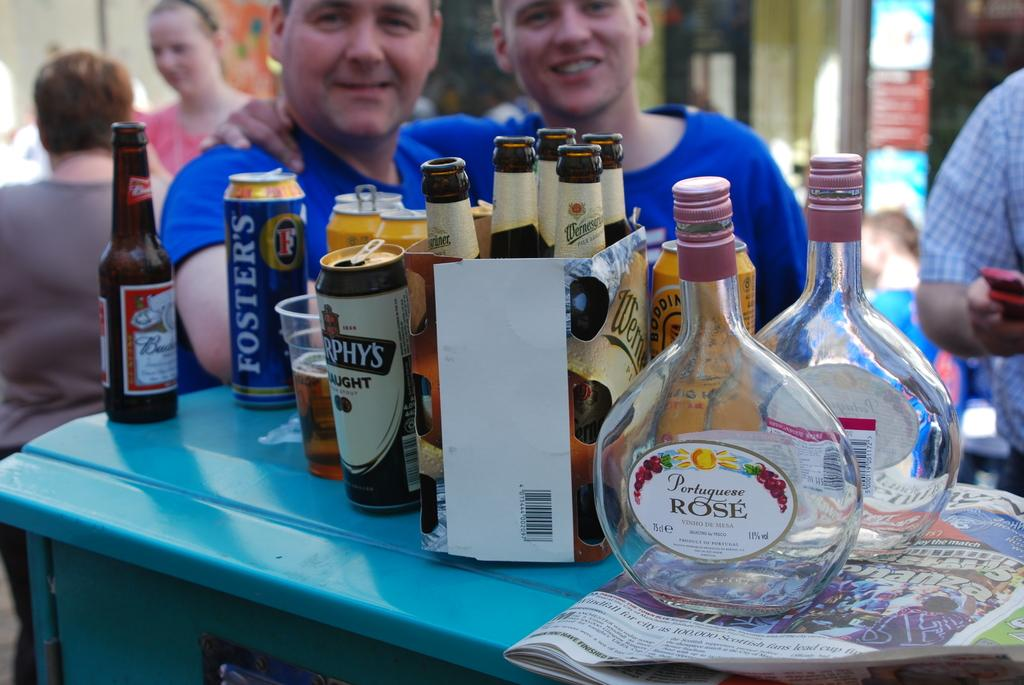<image>
Provide a brief description of the given image. A group of alcoholic beverages including an empty bottle of Portuguese Rose. 